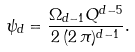Convert formula to latex. <formula><loc_0><loc_0><loc_500><loc_500>\psi _ { d } = \frac { \Omega _ { d - 1 } Q ^ { d - 5 } } { 2 \, ( 2 \, \pi ) ^ { d - 1 } } .</formula> 